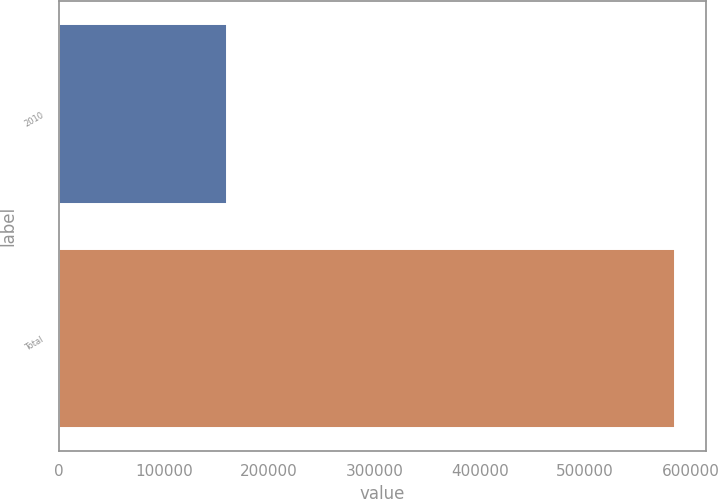<chart> <loc_0><loc_0><loc_500><loc_500><bar_chart><fcel>2010<fcel>Total<nl><fcel>160173<fcel>585472<nl></chart> 